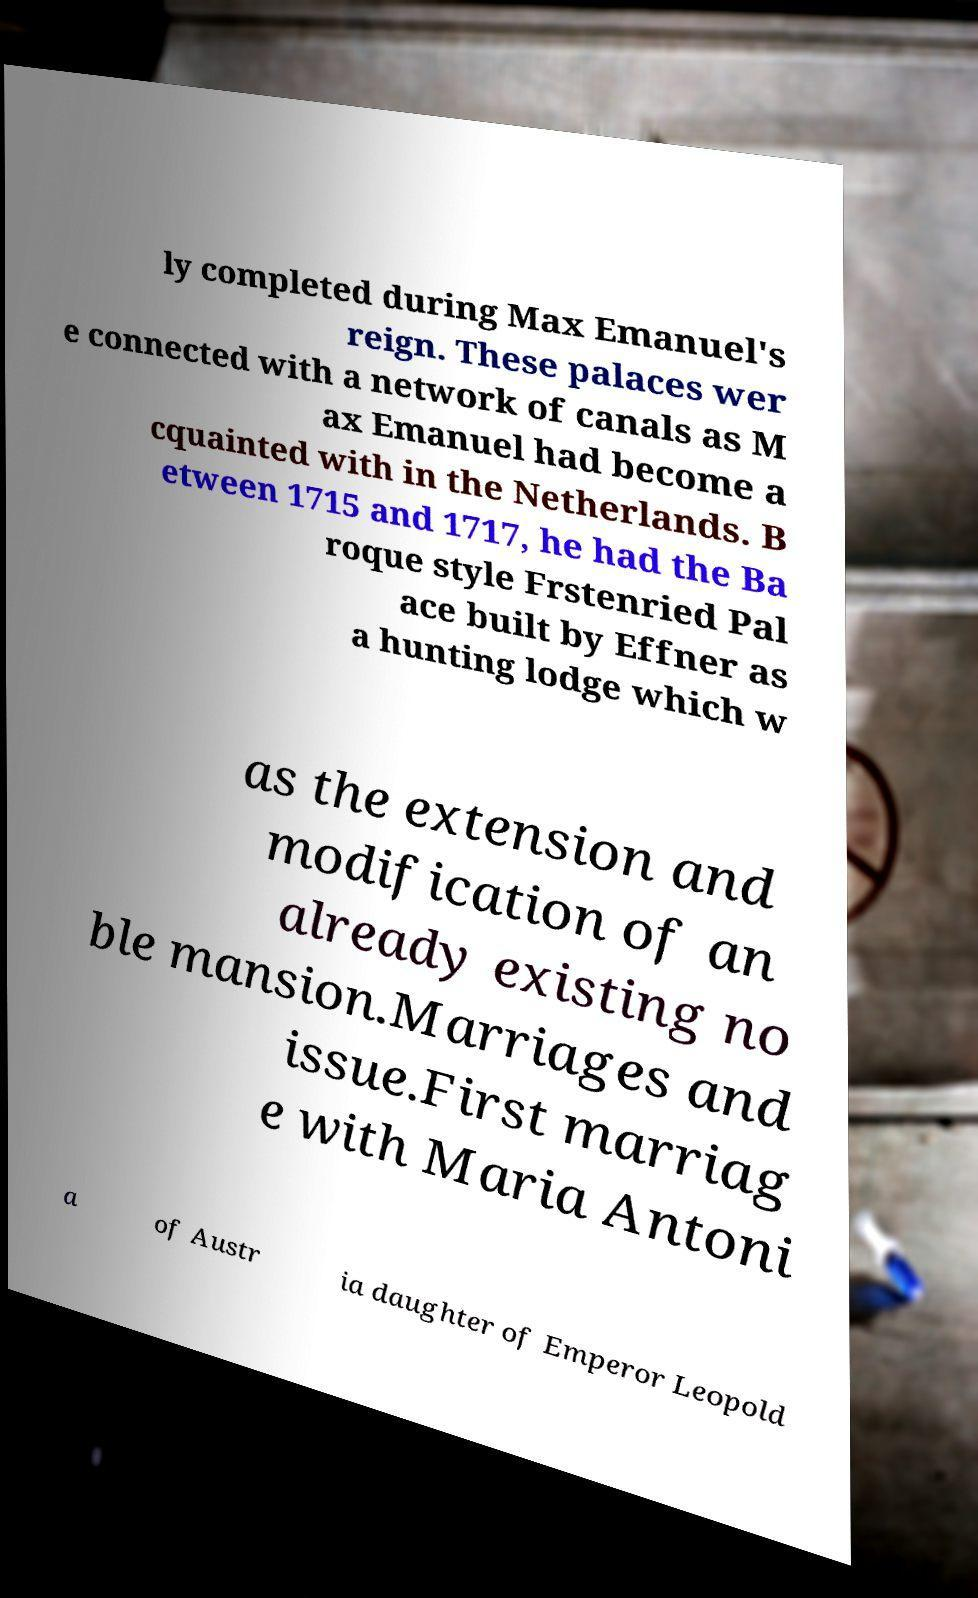I need the written content from this picture converted into text. Can you do that? ly completed during Max Emanuel's reign. These palaces wer e connected with a network of canals as M ax Emanuel had become a cquainted with in the Netherlands. B etween 1715 and 1717, he had the Ba roque style Frstenried Pal ace built by Effner as a hunting lodge which w as the extension and modification of an already existing no ble mansion.Marriages and issue.First marriag e with Maria Antoni a of Austr ia daughter of Emperor Leopold 